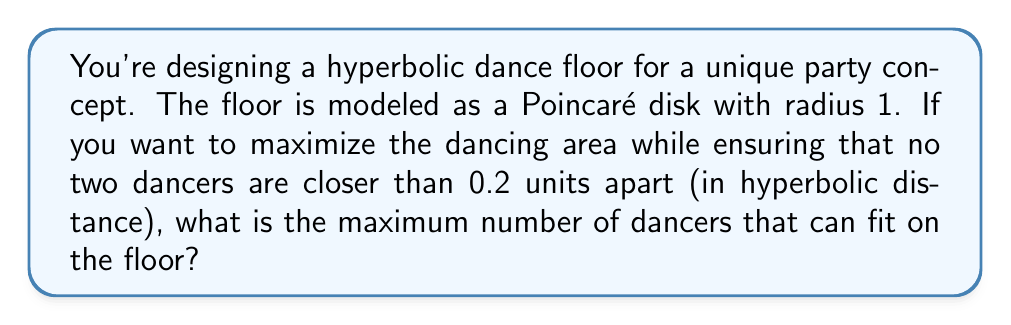Give your solution to this math problem. Let's approach this step-by-step:

1) In hyperbolic geometry, the area of a circle with radius $r$ in the Poincaré disk model is given by:

   $$A = 4\pi \sinh^2(\frac{r}{2})$$

2) The total area of the Poincaré disk with radius 1 is:

   $$A_{total} = 4\pi \sinh^2(\frac{1}{2}) \approx 4.6416$$

3) Each dancer occupies a hyperbolic circle with radius 0.1 (half the minimum distance). The area of this circle is:

   $$A_{dancer} = 4\pi \sinh^2(\frac{0.1}{2}) \approx 0.0314$$

4) To maximize the number of dancers, we need to find the densest packing of these circles in the hyperbolic plane. This is a complex problem, but it's known that the density of the densest packing in hyperbolic space is less than 1.

5) A good approximation for the density of the densest packing in hyperbolic space is about 0.85. Let's use this value.

6) The number of dancers that can fit is approximately:

   $$N = 0.85 \cdot \frac{A_{total}}{A_{dancer}} = 0.85 \cdot \frac{4.6416}{0.0314} \approx 125.7$$

7) Since we can't have a fractional number of dancers, we round down to the nearest whole number.
Answer: 125 dancers 